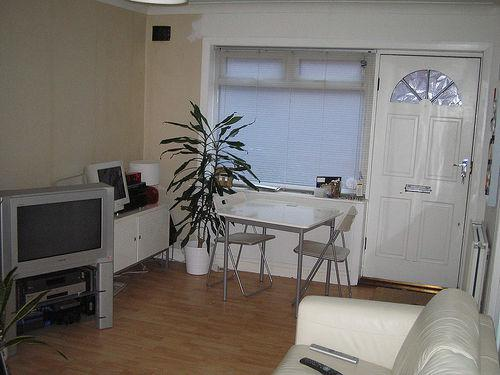Question: what is on the tv?
Choices:
A. American Idol.
B. The Wonder Years.
C. Nothing.
D. The news.
Answer with the letter. Answer: C 